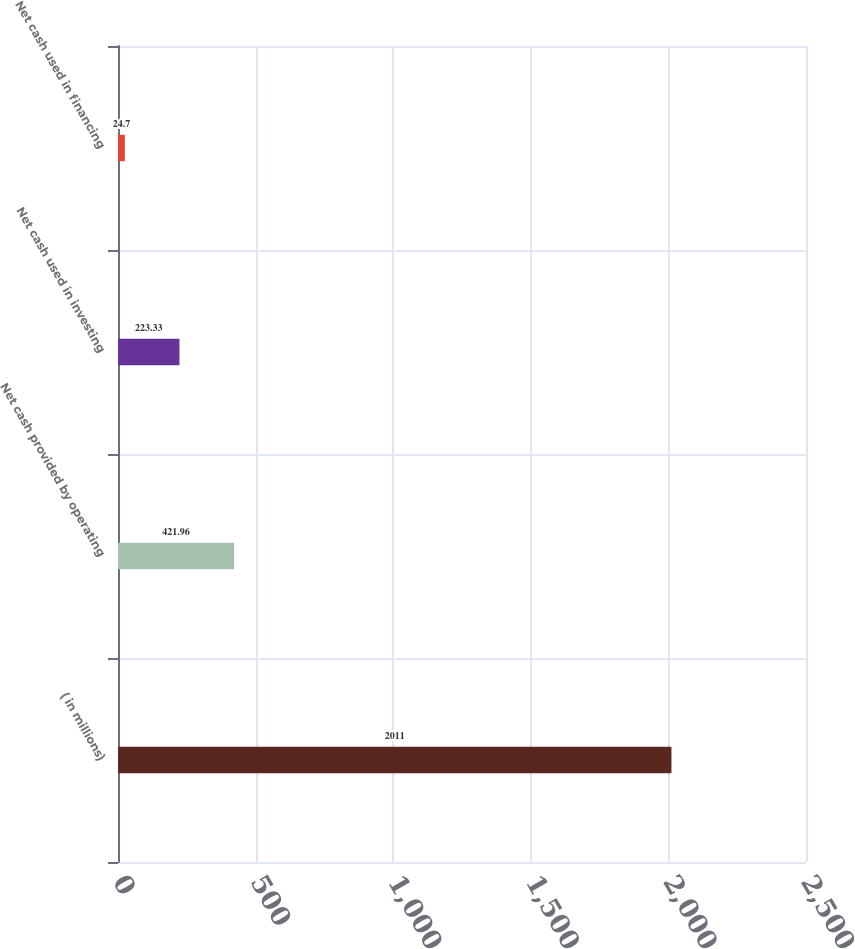Convert chart. <chart><loc_0><loc_0><loc_500><loc_500><bar_chart><fcel>( in millions)<fcel>Net cash provided by operating<fcel>Net cash used in investing<fcel>Net cash used in financing<nl><fcel>2011<fcel>421.96<fcel>223.33<fcel>24.7<nl></chart> 